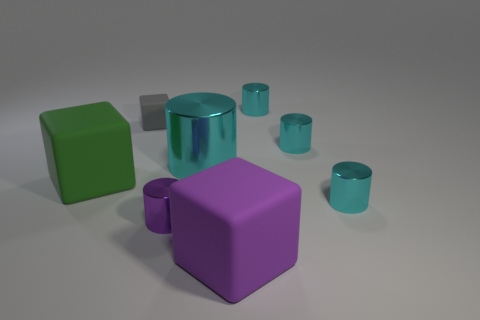Subtract all cyan cylinders. How many were subtracted if there are2cyan cylinders left? 2 Subtract all cyan metal cylinders. How many cylinders are left? 1 Add 1 tiny cyan cylinders. How many objects exist? 9 Subtract all large green rubber objects. Subtract all purple metal cylinders. How many objects are left? 6 Add 7 big cyan metallic cylinders. How many big cyan metallic cylinders are left? 8 Add 3 tiny red rubber things. How many tiny red rubber things exist? 3 Subtract all purple cylinders. How many cylinders are left? 4 Subtract 1 purple cubes. How many objects are left? 7 Subtract all cylinders. How many objects are left? 3 Subtract 1 cylinders. How many cylinders are left? 4 